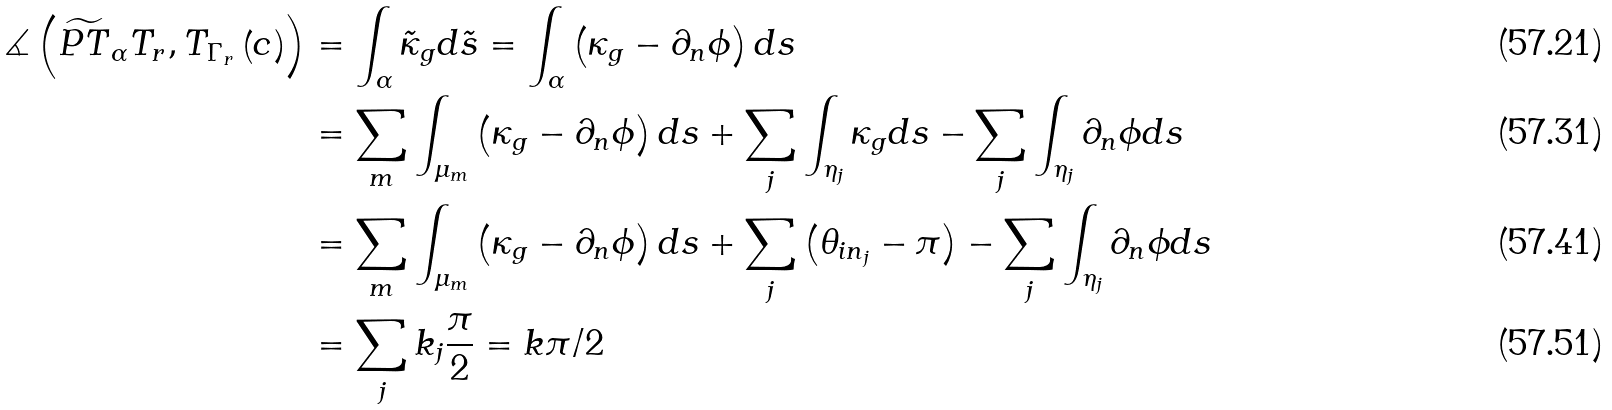<formula> <loc_0><loc_0><loc_500><loc_500>\measuredangle \left ( \widetilde { P T } _ { \alpha } T _ { r } , T _ { \Gamma _ { r } } \left ( c \right ) \right ) & = \int _ { \alpha } \tilde { \kappa } _ { g } d \tilde { s } = \int _ { \alpha } \left ( \kappa _ { g } - \partial _ { n } \phi \right ) d s \\ & = \sum _ { m } \int _ { \mu _ { m } } \left ( \kappa _ { g } - \partial _ { n } \phi \right ) d s + \sum _ { j } \int _ { \eta _ { j } } \kappa _ { g } d s - \sum _ { j } \int _ { \eta _ { j } } \partial _ { n } \phi d s \\ & = \sum _ { m } \int _ { \mu _ { m } } \left ( \kappa _ { g } - \partial _ { n } \phi \right ) d s + \sum _ { j } \left ( \theta _ { i n _ { j } } - \pi \right ) - \sum _ { j } \int _ { \eta _ { j } } \partial _ { n } \phi d s \\ & = \sum _ { j } k _ { j } \frac { \pi } { 2 } = k \pi / 2</formula> 